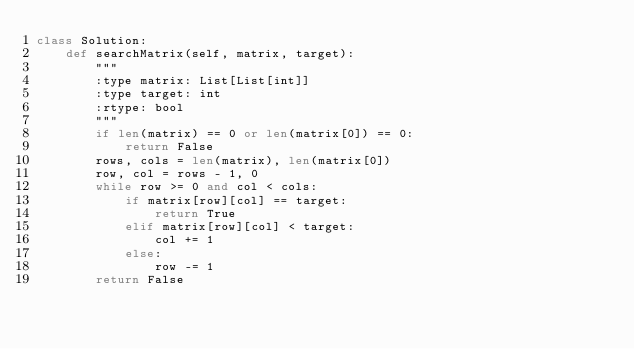Convert code to text. <code><loc_0><loc_0><loc_500><loc_500><_Python_>class Solution:
    def searchMatrix(self, matrix, target):
        """
        :type matrix: List[List[int]]
        :type target: int
        :rtype: bool
        """
        if len(matrix) == 0 or len(matrix[0]) == 0:
            return False
        rows, cols = len(matrix), len(matrix[0])
        row, col = rows - 1, 0
        while row >= 0 and col < cols:
            if matrix[row][col] == target:
                return True
            elif matrix[row][col] < target:
                col += 1
            else:
                row -= 1
        return False</code> 